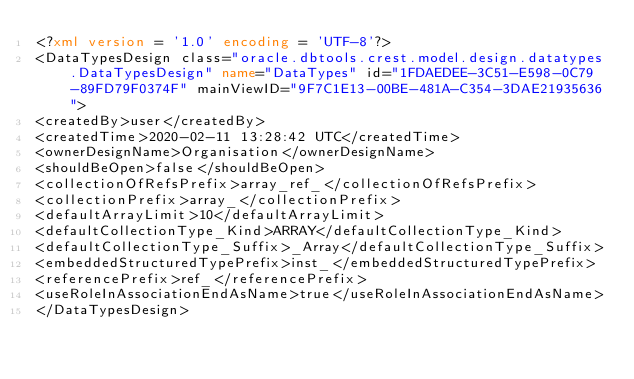<code> <loc_0><loc_0><loc_500><loc_500><_XML_><?xml version = '1.0' encoding = 'UTF-8'?>
<DataTypesDesign class="oracle.dbtools.crest.model.design.datatypes.DataTypesDesign" name="DataTypes" id="1FDAEDEE-3C51-E598-0C79-89FD79F0374F" mainViewID="9F7C1E13-00BE-481A-C354-3DAE21935636">
<createdBy>user</createdBy>
<createdTime>2020-02-11 13:28:42 UTC</createdTime>
<ownerDesignName>Organisation</ownerDesignName>
<shouldBeOpen>false</shouldBeOpen>
<collectionOfRefsPrefix>array_ref_</collectionOfRefsPrefix>
<collectionPrefix>array_</collectionPrefix>
<defaultArrayLimit>10</defaultArrayLimit>
<defaultCollectionType_Kind>ARRAY</defaultCollectionType_Kind>
<defaultCollectionType_Suffix>_Array</defaultCollectionType_Suffix>
<embeddedStructuredTypePrefix>inst_</embeddedStructuredTypePrefix>
<referencePrefix>ref_</referencePrefix>
<useRoleInAssociationEndAsName>true</useRoleInAssociationEndAsName>
</DataTypesDesign></code> 